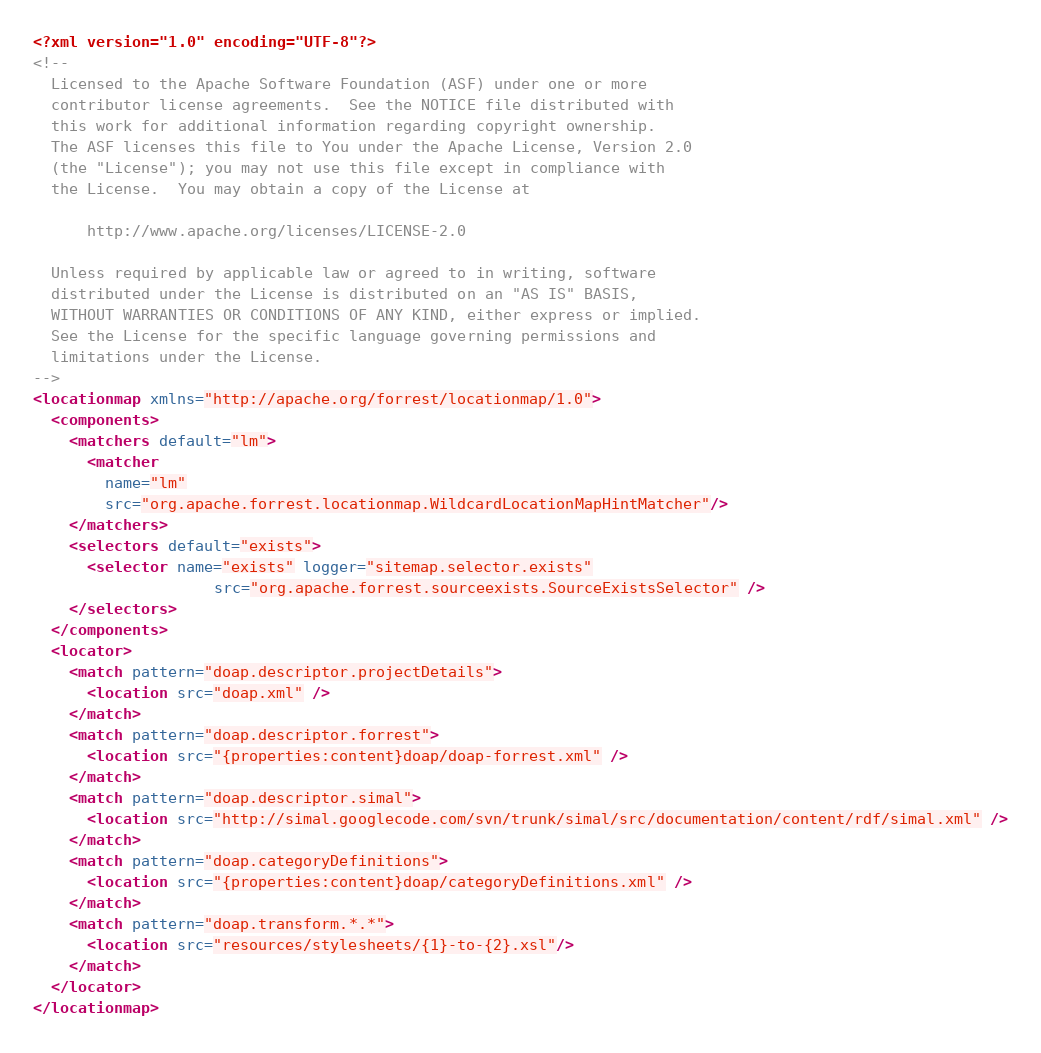Convert code to text. <code><loc_0><loc_0><loc_500><loc_500><_XML_><?xml version="1.0" encoding="UTF-8"?>
<!--
  Licensed to the Apache Software Foundation (ASF) under one or more
  contributor license agreements.  See the NOTICE file distributed with
  this work for additional information regarding copyright ownership.
  The ASF licenses this file to You under the Apache License, Version 2.0
  (the "License"); you may not use this file except in compliance with
  the License.  You may obtain a copy of the License at

      http://www.apache.org/licenses/LICENSE-2.0

  Unless required by applicable law or agreed to in writing, software
  distributed under the License is distributed on an "AS IS" BASIS,
  WITHOUT WARRANTIES OR CONDITIONS OF ANY KIND, either express or implied.
  See the License for the specific language governing permissions and
  limitations under the License.
-->
<locationmap xmlns="http://apache.org/forrest/locationmap/1.0">
  <components>
    <matchers default="lm">
      <matcher 
        name="lm" 
        src="org.apache.forrest.locationmap.WildcardLocationMapHintMatcher"/>
    </matchers>
    <selectors default="exists">
      <selector name="exists" logger="sitemap.selector.exists"  
                    src="org.apache.forrest.sourceexists.SourceExistsSelector" />
    </selectors>
  </components>
  <locator>
    <match pattern="doap.descriptor.projectDetails">
      <location src="doap.xml" />
    </match>
    <match pattern="doap.descriptor.forrest">
      <location src="{properties:content}doap/doap-forrest.xml" />
    </match>
    <match pattern="doap.descriptor.simal">
      <location src="http://simal.googlecode.com/svn/trunk/simal/src/documentation/content/rdf/simal.xml" />
    </match>
    <match pattern="doap.categoryDefinitions">
      <location src="{properties:content}doap/categoryDefinitions.xml" />
    </match>
    <match pattern="doap.transform.*.*">
      <location src="resources/stylesheets/{1}-to-{2}.xsl"/>
    </match>
  </locator>
</locationmap>
</code> 